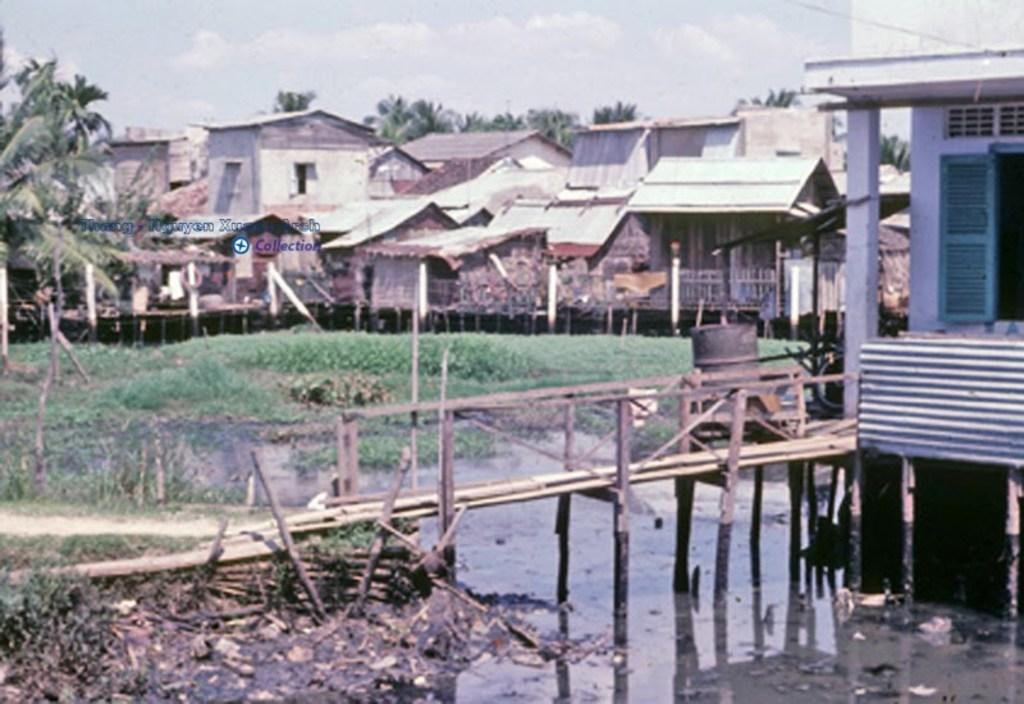What is the primary element visible in the image? There is water in the image. What type of structures can be seen in the image? There are wooden poles and buildings in the image. What is the ground covered with? The ground is covered with grass. What type of vegetation is present in the image? There are trees in the image. What is the condition of the sky in the image? The sky is cloudy in the image. What type of reward can be seen hanging from the trees in the image? There are no rewards hanging from the trees in the image; it only features water, wooden poles, buildings, grass, trees, and a cloudy sky. 